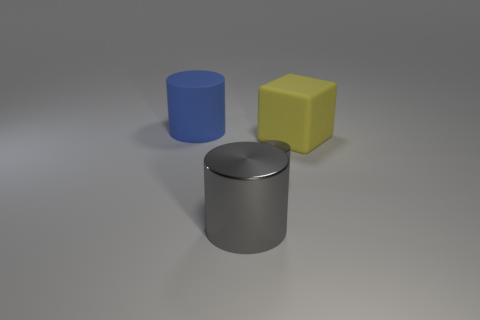Subtract all metallic cylinders. How many cylinders are left? 1 Subtract all gray cylinders. How many cylinders are left? 1 Subtract all cubes. How many objects are left? 3 Add 2 brown metallic things. How many objects exist? 6 Subtract all gray cubes. How many gray cylinders are left? 2 Subtract 2 gray cylinders. How many objects are left? 2 Subtract 2 cylinders. How many cylinders are left? 1 Subtract all red cubes. Subtract all gray cylinders. How many cubes are left? 1 Subtract all tiny cyan objects. Subtract all large things. How many objects are left? 1 Add 4 large matte cylinders. How many large matte cylinders are left? 5 